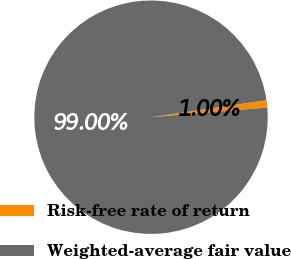Convert chart. <chart><loc_0><loc_0><loc_500><loc_500><pie_chart><fcel>Risk-free rate of return<fcel>Weighted-average fair value<nl><fcel>1.0%<fcel>99.0%<nl></chart> 